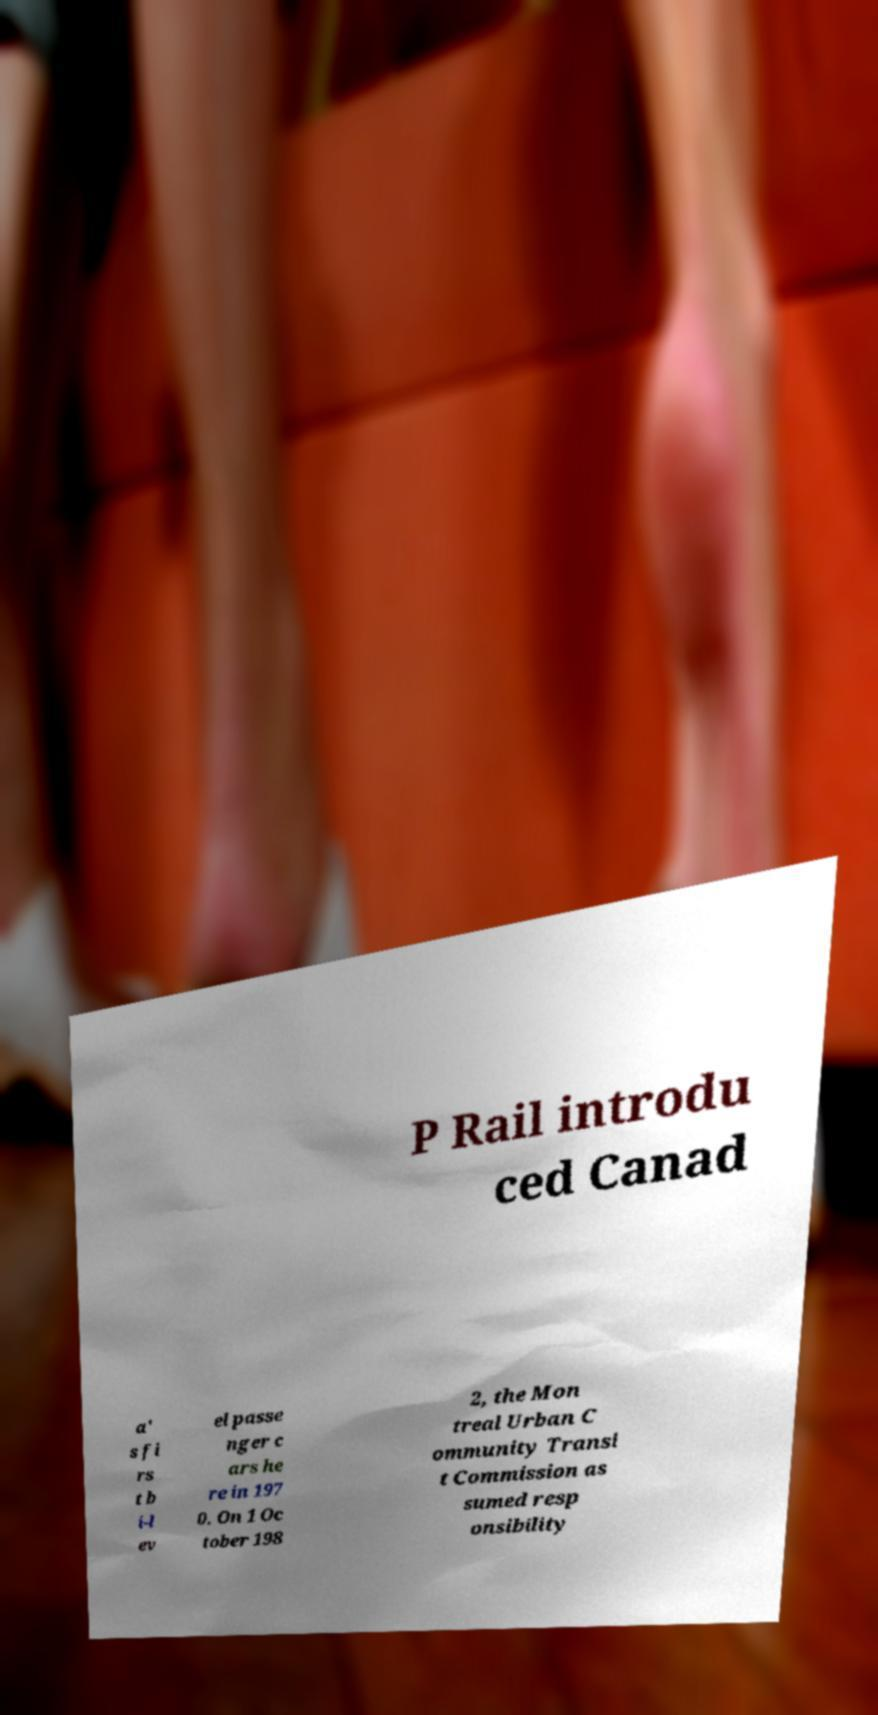Please read and relay the text visible in this image. What does it say? P Rail introdu ced Canad a' s fi rs t b i-l ev el passe nger c ars he re in 197 0. On 1 Oc tober 198 2, the Mon treal Urban C ommunity Transi t Commission as sumed resp onsibility 